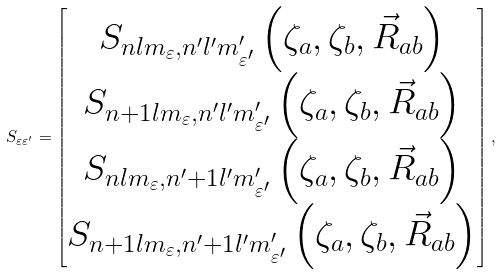<formula> <loc_0><loc_0><loc_500><loc_500>S _ { \varepsilon \varepsilon ^ { \prime } } = \begin{bmatrix} S _ { n l m _ { \varepsilon } , n ^ { \prime } l ^ { \prime } m ^ { \prime } _ { \varepsilon ^ { \prime } } } \left ( \zeta _ { a } , \zeta _ { b } , \vec { R } _ { a b } \right ) \\ S _ { n + 1 l m _ { \varepsilon } , n ^ { \prime } l ^ { \prime } m ^ { \prime } _ { \varepsilon ^ { \prime } } } \left ( \zeta _ { a } , \zeta _ { b } , \vec { R } _ { a b } \right ) \\ S _ { n l m _ { \varepsilon } , n ^ { \prime } + 1 l ^ { \prime } m ^ { \prime } _ { \varepsilon ^ { \prime } } } \left ( \zeta _ { a } , \zeta _ { b } , \vec { R } _ { a b } \right ) \\ S _ { n + 1 l m _ { \varepsilon } , n ^ { \prime } + 1 l ^ { \prime } m ^ { \prime } _ { \varepsilon ^ { \prime } } } \left ( \zeta _ { a } , \zeta _ { b } , \vec { R } _ { a b } \right ) \end{bmatrix} ,</formula> 